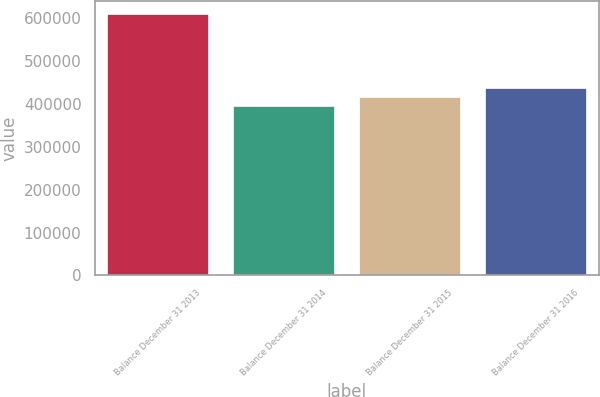Convert chart. <chart><loc_0><loc_0><loc_500><loc_500><bar_chart><fcel>Balance December 31 2013<fcel>Balance December 31 2014<fcel>Balance December 31 2015<fcel>Balance December 31 2016<nl><fcel>609363<fcel>395378<fcel>416776<fcel>438175<nl></chart> 